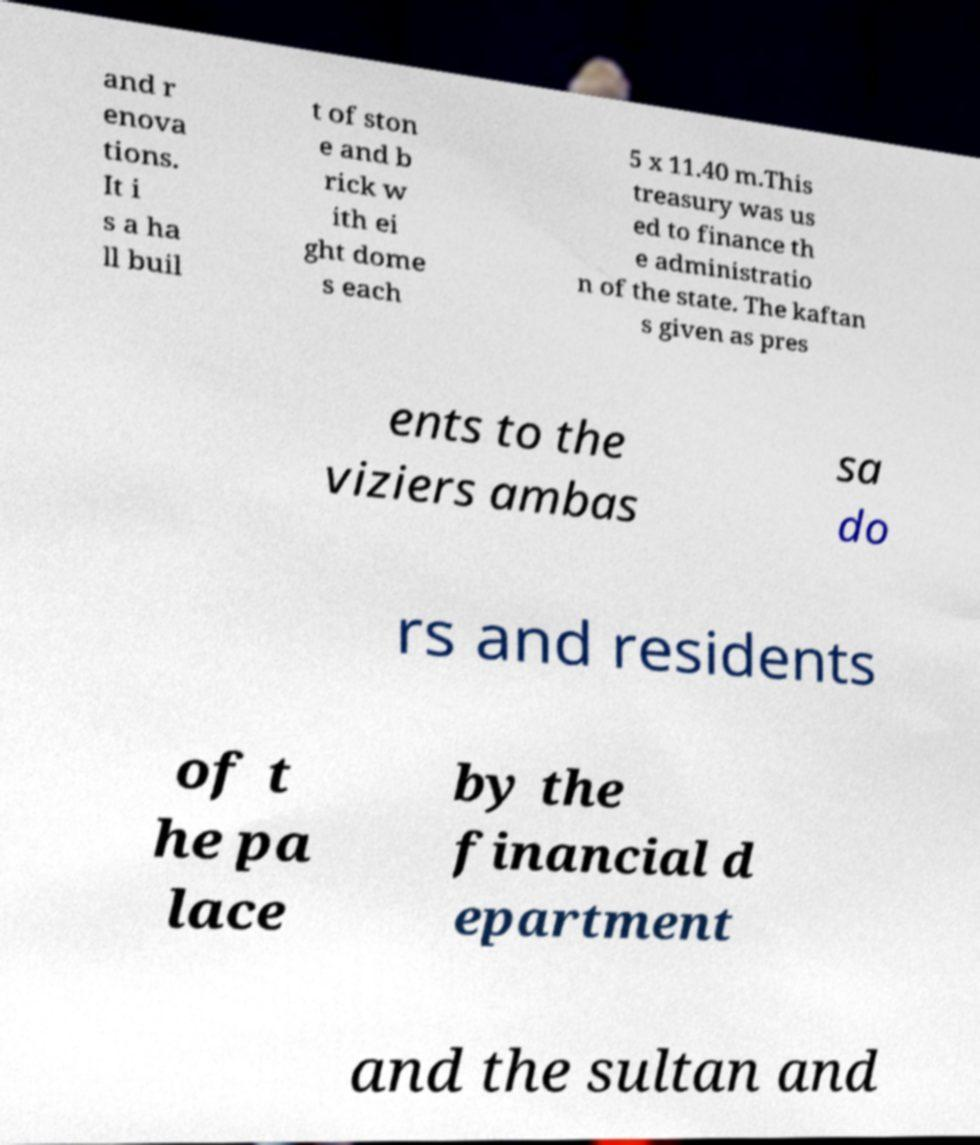What messages or text are displayed in this image? I need them in a readable, typed format. and r enova tions. It i s a ha ll buil t of ston e and b rick w ith ei ght dome s each 5 x 11.40 m.This treasury was us ed to finance th e administratio n of the state. The kaftan s given as pres ents to the viziers ambas sa do rs and residents of t he pa lace by the financial d epartment and the sultan and 